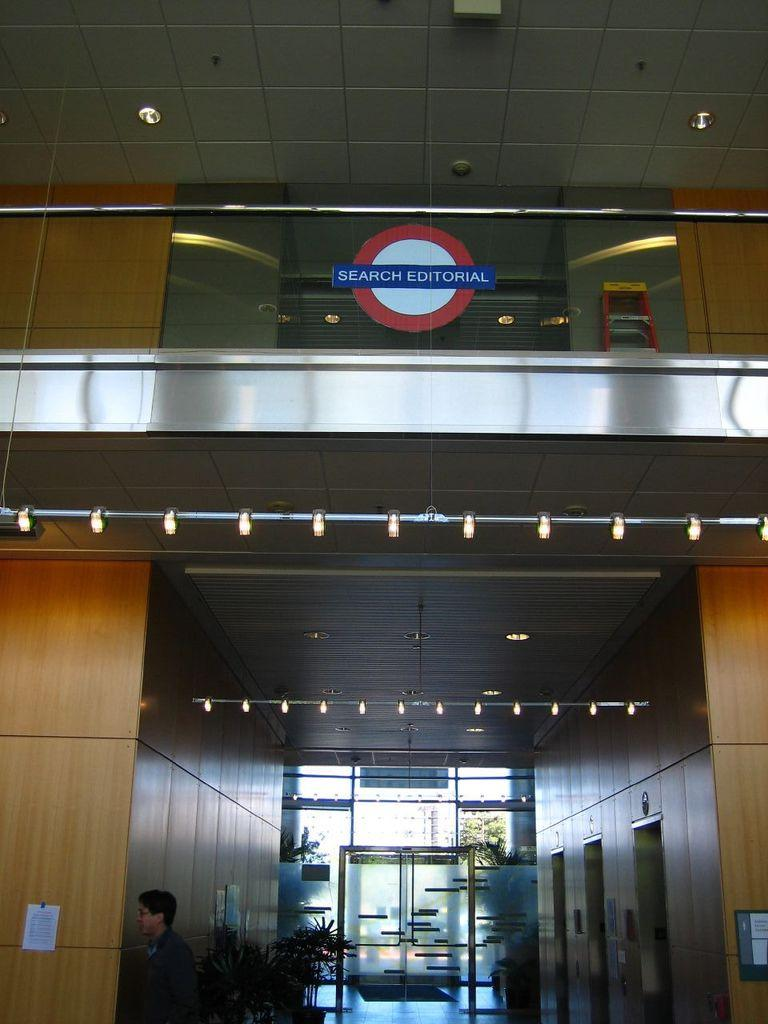What type of structure is present in the image? There is a building in the image. What else can be seen in the image besides the building? There are plants, a man walking, a paper, lights, and a door in the image. Can you describe the man's action in the image? The man is walking in the image. What might the paper be used for in the image? The paper could be used for various purposes, such as reading, writing, or carrying information. What type of rose is the man holding in the image? There is no rose present in the image; the man is simply walking. What type of juice is the paper soaked in within the image? There is no juice or liquid present on the paper in the image. 